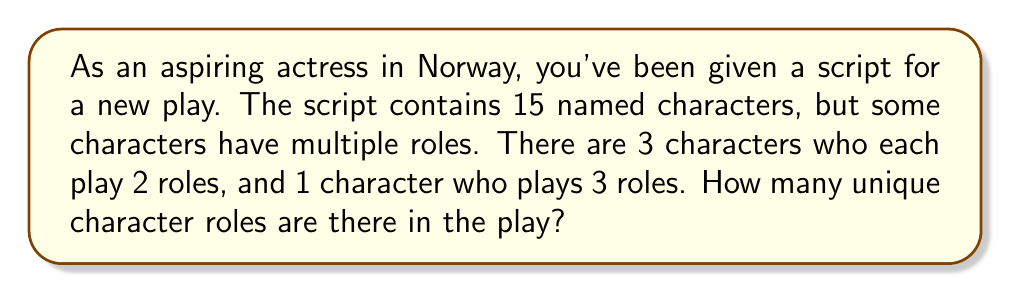Could you help me with this problem? Let's approach this step-by-step using set theory:

1. Let $A$ be the set of all character roles in the play.

2. We know there are 15 named characters in total. Let's call this number $n$. So initially, $|A| = 15$.

3. However, some characters play multiple roles:
   - 3 characters play 2 roles each
   - 1 character plays 3 roles

4. To find the total number of unique roles, we need to add these additional roles to our initial count:
   $$|A| = n + (3 \times 1) + (1 \times 2)$$

   Where:
   - $n = 15$ (initial number of characters)
   - $(3 \times 1)$ represents the 3 characters who each have 1 additional role
   - $(1 \times 2)$ represents the 1 character who has 2 additional roles

5. Substituting the values:
   $$|A| = 15 + 3 + 2 = 20$$

Therefore, there are 20 unique character roles in the play.
Answer: 20 unique character roles 